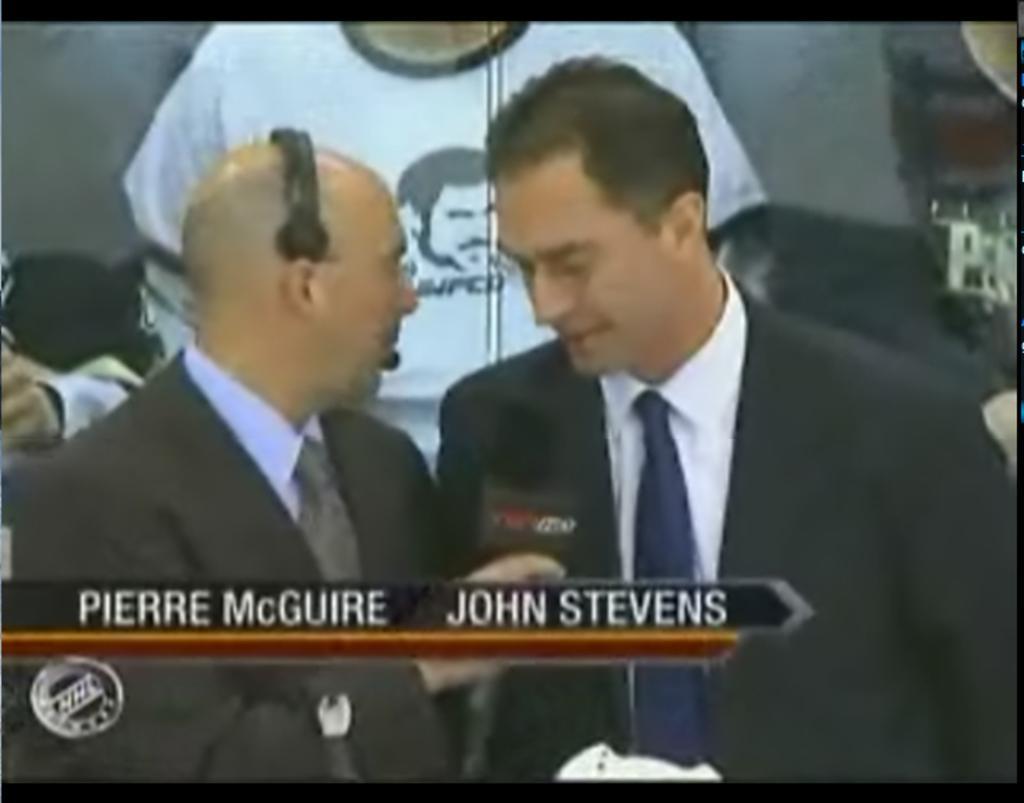How would you summarize this image in a sentence or two? Here we can see two men and they are in suits. In the background we can see a poster. 